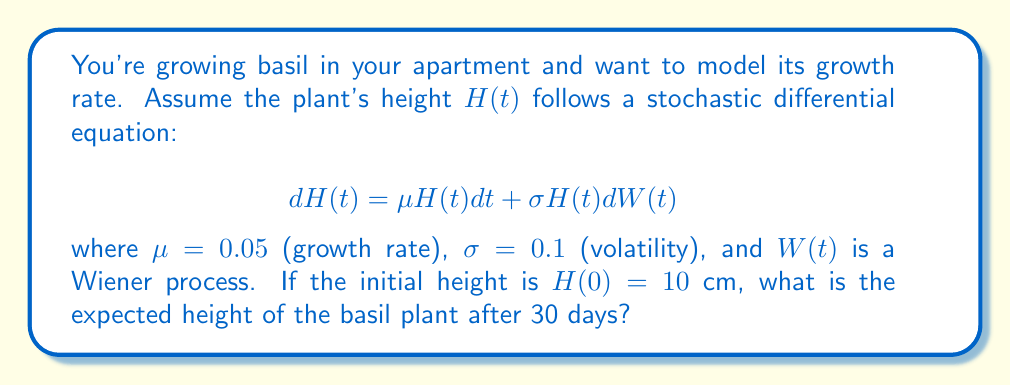Teach me how to tackle this problem. To solve this problem, we'll follow these steps:

1) The given stochastic differential equation is a geometric Brownian motion model.

2) For geometric Brownian motion, the expected value of $H(t)$ is given by:

   $$E[H(t)] = H(0)e^{\mu t}$$

3) We have:
   - $H(0) = 10$ cm (initial height)
   - $\mu = 0.05$ (growth rate)
   - $t = 30$ days

4) Substituting these values into the formula:

   $$E[H(30)] = 10 \cdot e^{0.05 \cdot 30}$$

5) Calculate:
   $$E[H(30)] = 10 \cdot e^{1.5} = 10 \cdot 4.4817 = 44.817$$

6) Round to two decimal places:

   $$E[H(30)] \approx 44.82 \text{ cm}$$

Therefore, the expected height of the basil plant after 30 days is approximately 44.82 cm.
Answer: 44.82 cm 